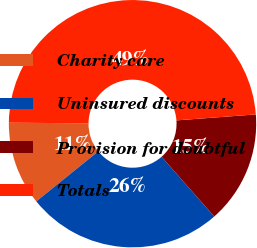Convert chart to OTSL. <chart><loc_0><loc_0><loc_500><loc_500><pie_chart><fcel>Charity care<fcel>Uninsured discounts<fcel>Provision for doubtful<fcel>Totals<nl><fcel>10.94%<fcel>25.68%<fcel>14.71%<fcel>48.68%<nl></chart> 